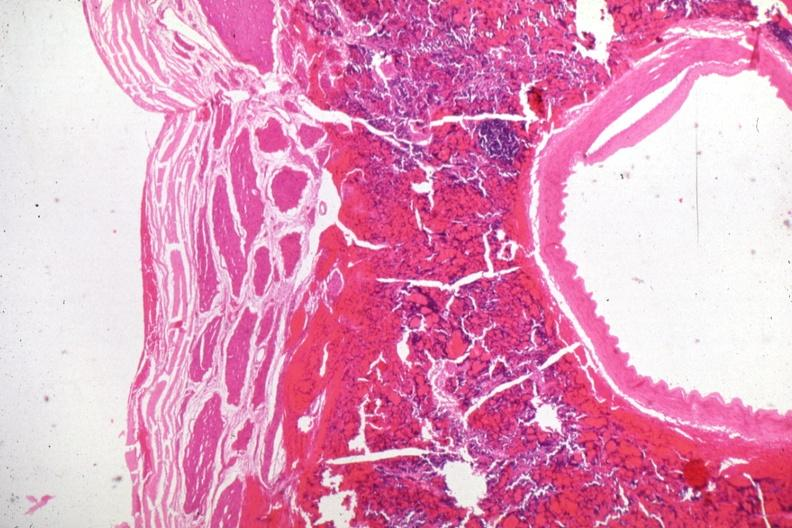what does this image show?
Answer the question using a single word or phrase. Carotid artery in region of pituitary with tumor cells in soft tissue 